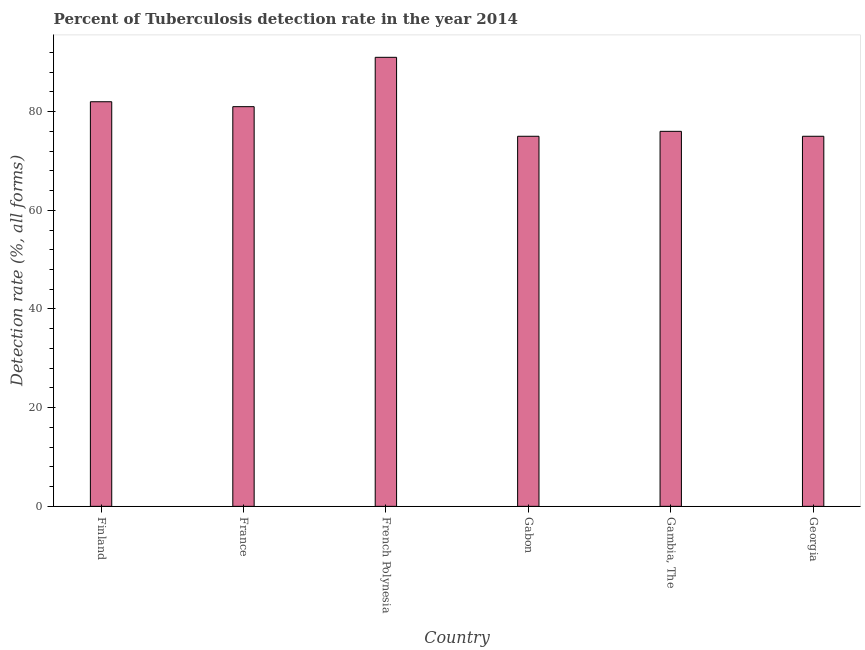Does the graph contain grids?
Provide a short and direct response. No. What is the title of the graph?
Your answer should be compact. Percent of Tuberculosis detection rate in the year 2014. What is the label or title of the X-axis?
Provide a succinct answer. Country. What is the label or title of the Y-axis?
Your answer should be compact. Detection rate (%, all forms). Across all countries, what is the maximum detection rate of tuberculosis?
Keep it short and to the point. 91. In which country was the detection rate of tuberculosis maximum?
Provide a succinct answer. French Polynesia. In which country was the detection rate of tuberculosis minimum?
Your response must be concise. Gabon. What is the sum of the detection rate of tuberculosis?
Ensure brevity in your answer.  480. What is the difference between the detection rate of tuberculosis in Finland and French Polynesia?
Your answer should be compact. -9. What is the median detection rate of tuberculosis?
Keep it short and to the point. 78.5. Is the difference between the detection rate of tuberculosis in France and Georgia greater than the difference between any two countries?
Ensure brevity in your answer.  No. What is the difference between the highest and the second highest detection rate of tuberculosis?
Your response must be concise. 9. Is the sum of the detection rate of tuberculosis in Finland and France greater than the maximum detection rate of tuberculosis across all countries?
Ensure brevity in your answer.  Yes. What is the difference between the highest and the lowest detection rate of tuberculosis?
Ensure brevity in your answer.  16. What is the difference between two consecutive major ticks on the Y-axis?
Provide a succinct answer. 20. Are the values on the major ticks of Y-axis written in scientific E-notation?
Your response must be concise. No. What is the Detection rate (%, all forms) of Finland?
Offer a very short reply. 82. What is the Detection rate (%, all forms) of French Polynesia?
Your answer should be compact. 91. What is the Detection rate (%, all forms) in Gambia, The?
Keep it short and to the point. 76. What is the difference between the Detection rate (%, all forms) in Finland and France?
Ensure brevity in your answer.  1. What is the difference between the Detection rate (%, all forms) in Finland and Gabon?
Offer a terse response. 7. What is the difference between the Detection rate (%, all forms) in France and Gabon?
Offer a terse response. 6. What is the difference between the Detection rate (%, all forms) in French Polynesia and Gabon?
Your response must be concise. 16. What is the difference between the Detection rate (%, all forms) in Gabon and Georgia?
Make the answer very short. 0. What is the difference between the Detection rate (%, all forms) in Gambia, The and Georgia?
Make the answer very short. 1. What is the ratio of the Detection rate (%, all forms) in Finland to that in France?
Give a very brief answer. 1.01. What is the ratio of the Detection rate (%, all forms) in Finland to that in French Polynesia?
Offer a terse response. 0.9. What is the ratio of the Detection rate (%, all forms) in Finland to that in Gabon?
Keep it short and to the point. 1.09. What is the ratio of the Detection rate (%, all forms) in Finland to that in Gambia, The?
Offer a very short reply. 1.08. What is the ratio of the Detection rate (%, all forms) in Finland to that in Georgia?
Keep it short and to the point. 1.09. What is the ratio of the Detection rate (%, all forms) in France to that in French Polynesia?
Keep it short and to the point. 0.89. What is the ratio of the Detection rate (%, all forms) in France to that in Gambia, The?
Give a very brief answer. 1.07. What is the ratio of the Detection rate (%, all forms) in French Polynesia to that in Gabon?
Give a very brief answer. 1.21. What is the ratio of the Detection rate (%, all forms) in French Polynesia to that in Gambia, The?
Your response must be concise. 1.2. What is the ratio of the Detection rate (%, all forms) in French Polynesia to that in Georgia?
Provide a succinct answer. 1.21. What is the ratio of the Detection rate (%, all forms) in Gabon to that in Gambia, The?
Your answer should be very brief. 0.99. What is the ratio of the Detection rate (%, all forms) in Gabon to that in Georgia?
Offer a terse response. 1. 